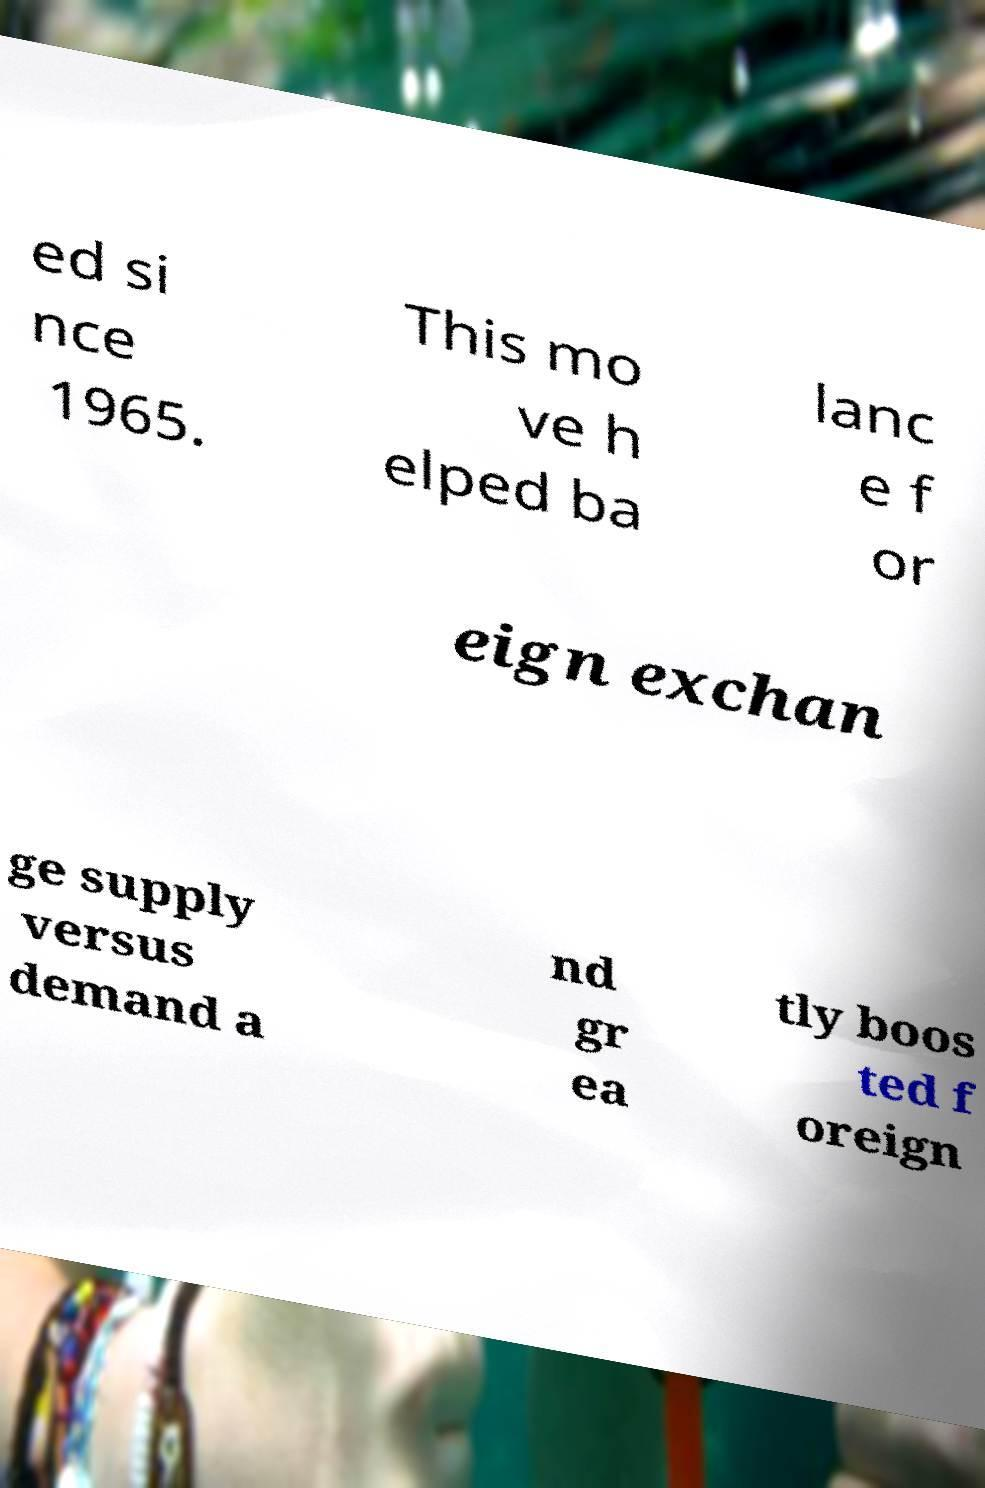Please read and relay the text visible in this image. What does it say? ed si nce 1965. This mo ve h elped ba lanc e f or eign exchan ge supply versus demand a nd gr ea tly boos ted f oreign 